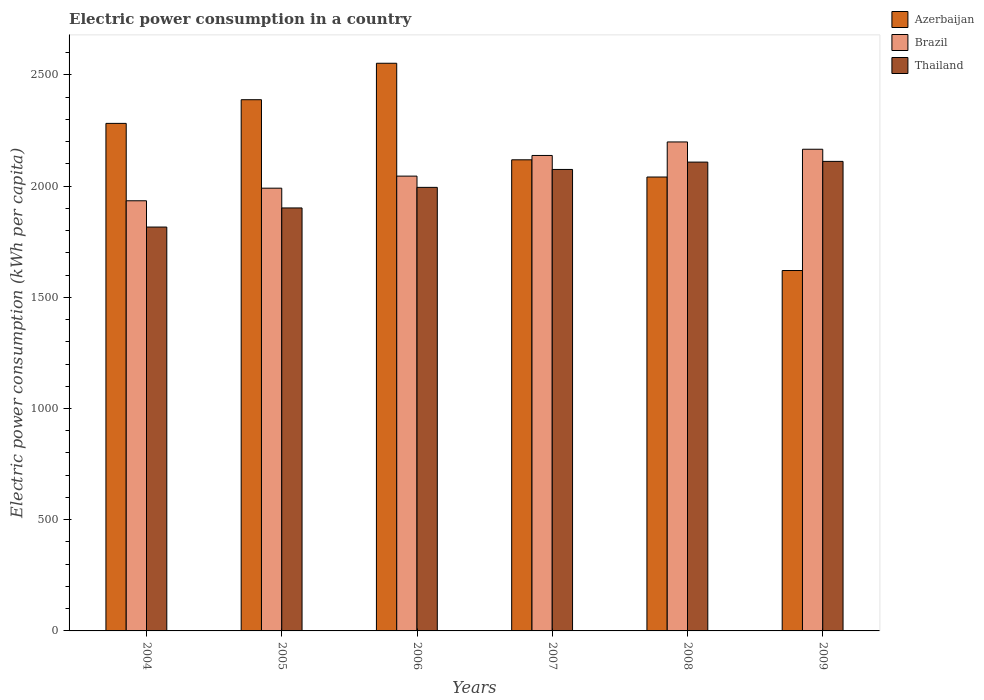How many groups of bars are there?
Make the answer very short. 6. Are the number of bars per tick equal to the number of legend labels?
Offer a very short reply. Yes. Are the number of bars on each tick of the X-axis equal?
Ensure brevity in your answer.  Yes. How many bars are there on the 4th tick from the left?
Keep it short and to the point. 3. In how many cases, is the number of bars for a given year not equal to the number of legend labels?
Provide a short and direct response. 0. What is the electric power consumption in in Brazil in 2006?
Your answer should be very brief. 2044.86. Across all years, what is the maximum electric power consumption in in Thailand?
Your answer should be compact. 2111.13. Across all years, what is the minimum electric power consumption in in Brazil?
Your answer should be compact. 1933.98. In which year was the electric power consumption in in Brazil maximum?
Offer a very short reply. 2008. What is the total electric power consumption in in Azerbaijan in the graph?
Keep it short and to the point. 1.30e+04. What is the difference between the electric power consumption in in Thailand in 2008 and that in 2009?
Make the answer very short. -3.23. What is the difference between the electric power consumption in in Thailand in 2008 and the electric power consumption in in Brazil in 2009?
Offer a very short reply. -57.78. What is the average electric power consumption in in Azerbaijan per year?
Your answer should be compact. 2167. In the year 2004, what is the difference between the electric power consumption in in Thailand and electric power consumption in in Azerbaijan?
Provide a succinct answer. -466.14. What is the ratio of the electric power consumption in in Brazil in 2004 to that in 2006?
Offer a very short reply. 0.95. Is the electric power consumption in in Brazil in 2005 less than that in 2009?
Offer a very short reply. Yes. Is the difference between the electric power consumption in in Thailand in 2004 and 2007 greater than the difference between the electric power consumption in in Azerbaijan in 2004 and 2007?
Provide a succinct answer. No. What is the difference between the highest and the second highest electric power consumption in in Azerbaijan?
Your answer should be compact. 163.9. What is the difference between the highest and the lowest electric power consumption in in Thailand?
Keep it short and to the point. 295.32. What does the 1st bar from the left in 2008 represents?
Your response must be concise. Azerbaijan. What does the 3rd bar from the right in 2008 represents?
Your answer should be compact. Azerbaijan. Is it the case that in every year, the sum of the electric power consumption in in Brazil and electric power consumption in in Azerbaijan is greater than the electric power consumption in in Thailand?
Your answer should be very brief. Yes. How many bars are there?
Provide a short and direct response. 18. How many years are there in the graph?
Offer a terse response. 6. Are the values on the major ticks of Y-axis written in scientific E-notation?
Give a very brief answer. No. Does the graph contain any zero values?
Keep it short and to the point. No. Where does the legend appear in the graph?
Keep it short and to the point. Top right. How are the legend labels stacked?
Provide a short and direct response. Vertical. What is the title of the graph?
Offer a very short reply. Electric power consumption in a country. What is the label or title of the X-axis?
Offer a very short reply. Years. What is the label or title of the Y-axis?
Give a very brief answer. Electric power consumption (kWh per capita). What is the Electric power consumption (kWh per capita) in Azerbaijan in 2004?
Your response must be concise. 2281.95. What is the Electric power consumption (kWh per capita) in Brazil in 2004?
Ensure brevity in your answer.  1933.98. What is the Electric power consumption (kWh per capita) in Thailand in 2004?
Your answer should be very brief. 1815.81. What is the Electric power consumption (kWh per capita) of Azerbaijan in 2005?
Provide a succinct answer. 2388.39. What is the Electric power consumption (kWh per capita) of Brazil in 2005?
Your answer should be very brief. 1990.64. What is the Electric power consumption (kWh per capita) of Thailand in 2005?
Make the answer very short. 1901.78. What is the Electric power consumption (kWh per capita) of Azerbaijan in 2006?
Keep it short and to the point. 2552.29. What is the Electric power consumption (kWh per capita) of Brazil in 2006?
Provide a succinct answer. 2044.86. What is the Electric power consumption (kWh per capita) in Thailand in 2006?
Your response must be concise. 1994.29. What is the Electric power consumption (kWh per capita) in Azerbaijan in 2007?
Give a very brief answer. 2118.21. What is the Electric power consumption (kWh per capita) in Brazil in 2007?
Make the answer very short. 2137.76. What is the Electric power consumption (kWh per capita) of Thailand in 2007?
Make the answer very short. 2074.87. What is the Electric power consumption (kWh per capita) of Azerbaijan in 2008?
Ensure brevity in your answer.  2040.76. What is the Electric power consumption (kWh per capita) of Brazil in 2008?
Make the answer very short. 2198.48. What is the Electric power consumption (kWh per capita) of Thailand in 2008?
Your response must be concise. 2107.9. What is the Electric power consumption (kWh per capita) in Azerbaijan in 2009?
Your answer should be very brief. 1620.39. What is the Electric power consumption (kWh per capita) in Brazil in 2009?
Make the answer very short. 2165.68. What is the Electric power consumption (kWh per capita) of Thailand in 2009?
Make the answer very short. 2111.13. Across all years, what is the maximum Electric power consumption (kWh per capita) in Azerbaijan?
Provide a succinct answer. 2552.29. Across all years, what is the maximum Electric power consumption (kWh per capita) in Brazil?
Ensure brevity in your answer.  2198.48. Across all years, what is the maximum Electric power consumption (kWh per capita) in Thailand?
Make the answer very short. 2111.13. Across all years, what is the minimum Electric power consumption (kWh per capita) of Azerbaijan?
Provide a short and direct response. 1620.39. Across all years, what is the minimum Electric power consumption (kWh per capita) in Brazil?
Offer a terse response. 1933.98. Across all years, what is the minimum Electric power consumption (kWh per capita) of Thailand?
Offer a terse response. 1815.81. What is the total Electric power consumption (kWh per capita) of Azerbaijan in the graph?
Your response must be concise. 1.30e+04. What is the total Electric power consumption (kWh per capita) in Brazil in the graph?
Offer a terse response. 1.25e+04. What is the total Electric power consumption (kWh per capita) of Thailand in the graph?
Keep it short and to the point. 1.20e+04. What is the difference between the Electric power consumption (kWh per capita) of Azerbaijan in 2004 and that in 2005?
Keep it short and to the point. -106.44. What is the difference between the Electric power consumption (kWh per capita) in Brazil in 2004 and that in 2005?
Provide a succinct answer. -56.66. What is the difference between the Electric power consumption (kWh per capita) in Thailand in 2004 and that in 2005?
Provide a succinct answer. -85.98. What is the difference between the Electric power consumption (kWh per capita) of Azerbaijan in 2004 and that in 2006?
Your response must be concise. -270.34. What is the difference between the Electric power consumption (kWh per capita) of Brazil in 2004 and that in 2006?
Make the answer very short. -110.88. What is the difference between the Electric power consumption (kWh per capita) in Thailand in 2004 and that in 2006?
Offer a very short reply. -178.48. What is the difference between the Electric power consumption (kWh per capita) in Azerbaijan in 2004 and that in 2007?
Your answer should be compact. 163.74. What is the difference between the Electric power consumption (kWh per capita) in Brazil in 2004 and that in 2007?
Give a very brief answer. -203.78. What is the difference between the Electric power consumption (kWh per capita) of Thailand in 2004 and that in 2007?
Your answer should be compact. -259.06. What is the difference between the Electric power consumption (kWh per capita) in Azerbaijan in 2004 and that in 2008?
Your response must be concise. 241.19. What is the difference between the Electric power consumption (kWh per capita) of Brazil in 2004 and that in 2008?
Offer a terse response. -264.5. What is the difference between the Electric power consumption (kWh per capita) in Thailand in 2004 and that in 2008?
Provide a succinct answer. -292.1. What is the difference between the Electric power consumption (kWh per capita) of Azerbaijan in 2004 and that in 2009?
Give a very brief answer. 661.56. What is the difference between the Electric power consumption (kWh per capita) of Brazil in 2004 and that in 2009?
Provide a succinct answer. -231.7. What is the difference between the Electric power consumption (kWh per capita) in Thailand in 2004 and that in 2009?
Offer a very short reply. -295.32. What is the difference between the Electric power consumption (kWh per capita) of Azerbaijan in 2005 and that in 2006?
Offer a very short reply. -163.9. What is the difference between the Electric power consumption (kWh per capita) in Brazil in 2005 and that in 2006?
Your answer should be compact. -54.22. What is the difference between the Electric power consumption (kWh per capita) in Thailand in 2005 and that in 2006?
Keep it short and to the point. -92.5. What is the difference between the Electric power consumption (kWh per capita) of Azerbaijan in 2005 and that in 2007?
Keep it short and to the point. 270.18. What is the difference between the Electric power consumption (kWh per capita) of Brazil in 2005 and that in 2007?
Give a very brief answer. -147.12. What is the difference between the Electric power consumption (kWh per capita) in Thailand in 2005 and that in 2007?
Give a very brief answer. -173.09. What is the difference between the Electric power consumption (kWh per capita) of Azerbaijan in 2005 and that in 2008?
Provide a short and direct response. 347.63. What is the difference between the Electric power consumption (kWh per capita) of Brazil in 2005 and that in 2008?
Ensure brevity in your answer.  -207.84. What is the difference between the Electric power consumption (kWh per capita) in Thailand in 2005 and that in 2008?
Ensure brevity in your answer.  -206.12. What is the difference between the Electric power consumption (kWh per capita) of Azerbaijan in 2005 and that in 2009?
Your answer should be very brief. 768. What is the difference between the Electric power consumption (kWh per capita) of Brazil in 2005 and that in 2009?
Give a very brief answer. -175.04. What is the difference between the Electric power consumption (kWh per capita) of Thailand in 2005 and that in 2009?
Provide a short and direct response. -209.35. What is the difference between the Electric power consumption (kWh per capita) in Azerbaijan in 2006 and that in 2007?
Offer a very short reply. 434.08. What is the difference between the Electric power consumption (kWh per capita) in Brazil in 2006 and that in 2007?
Make the answer very short. -92.91. What is the difference between the Electric power consumption (kWh per capita) of Thailand in 2006 and that in 2007?
Your answer should be compact. -80.58. What is the difference between the Electric power consumption (kWh per capita) in Azerbaijan in 2006 and that in 2008?
Ensure brevity in your answer.  511.53. What is the difference between the Electric power consumption (kWh per capita) of Brazil in 2006 and that in 2008?
Keep it short and to the point. -153.62. What is the difference between the Electric power consumption (kWh per capita) in Thailand in 2006 and that in 2008?
Your answer should be very brief. -113.61. What is the difference between the Electric power consumption (kWh per capita) of Azerbaijan in 2006 and that in 2009?
Your answer should be compact. 931.9. What is the difference between the Electric power consumption (kWh per capita) of Brazil in 2006 and that in 2009?
Your answer should be very brief. -120.83. What is the difference between the Electric power consumption (kWh per capita) in Thailand in 2006 and that in 2009?
Your answer should be very brief. -116.84. What is the difference between the Electric power consumption (kWh per capita) in Azerbaijan in 2007 and that in 2008?
Your answer should be very brief. 77.45. What is the difference between the Electric power consumption (kWh per capita) of Brazil in 2007 and that in 2008?
Your answer should be very brief. -60.72. What is the difference between the Electric power consumption (kWh per capita) of Thailand in 2007 and that in 2008?
Provide a short and direct response. -33.03. What is the difference between the Electric power consumption (kWh per capita) in Azerbaijan in 2007 and that in 2009?
Your answer should be compact. 497.82. What is the difference between the Electric power consumption (kWh per capita) in Brazil in 2007 and that in 2009?
Give a very brief answer. -27.92. What is the difference between the Electric power consumption (kWh per capita) of Thailand in 2007 and that in 2009?
Make the answer very short. -36.26. What is the difference between the Electric power consumption (kWh per capita) in Azerbaijan in 2008 and that in 2009?
Provide a short and direct response. 420.37. What is the difference between the Electric power consumption (kWh per capita) of Brazil in 2008 and that in 2009?
Your answer should be compact. 32.8. What is the difference between the Electric power consumption (kWh per capita) of Thailand in 2008 and that in 2009?
Offer a terse response. -3.23. What is the difference between the Electric power consumption (kWh per capita) in Azerbaijan in 2004 and the Electric power consumption (kWh per capita) in Brazil in 2005?
Ensure brevity in your answer.  291.3. What is the difference between the Electric power consumption (kWh per capita) of Azerbaijan in 2004 and the Electric power consumption (kWh per capita) of Thailand in 2005?
Make the answer very short. 380.16. What is the difference between the Electric power consumption (kWh per capita) of Brazil in 2004 and the Electric power consumption (kWh per capita) of Thailand in 2005?
Give a very brief answer. 32.2. What is the difference between the Electric power consumption (kWh per capita) of Azerbaijan in 2004 and the Electric power consumption (kWh per capita) of Brazil in 2006?
Give a very brief answer. 237.09. What is the difference between the Electric power consumption (kWh per capita) in Azerbaijan in 2004 and the Electric power consumption (kWh per capita) in Thailand in 2006?
Your answer should be compact. 287.66. What is the difference between the Electric power consumption (kWh per capita) of Brazil in 2004 and the Electric power consumption (kWh per capita) of Thailand in 2006?
Offer a very short reply. -60.3. What is the difference between the Electric power consumption (kWh per capita) of Azerbaijan in 2004 and the Electric power consumption (kWh per capita) of Brazil in 2007?
Ensure brevity in your answer.  144.18. What is the difference between the Electric power consumption (kWh per capita) of Azerbaijan in 2004 and the Electric power consumption (kWh per capita) of Thailand in 2007?
Provide a short and direct response. 207.08. What is the difference between the Electric power consumption (kWh per capita) of Brazil in 2004 and the Electric power consumption (kWh per capita) of Thailand in 2007?
Your answer should be compact. -140.89. What is the difference between the Electric power consumption (kWh per capita) in Azerbaijan in 2004 and the Electric power consumption (kWh per capita) in Brazil in 2008?
Your response must be concise. 83.46. What is the difference between the Electric power consumption (kWh per capita) in Azerbaijan in 2004 and the Electric power consumption (kWh per capita) in Thailand in 2008?
Ensure brevity in your answer.  174.05. What is the difference between the Electric power consumption (kWh per capita) in Brazil in 2004 and the Electric power consumption (kWh per capita) in Thailand in 2008?
Provide a succinct answer. -173.92. What is the difference between the Electric power consumption (kWh per capita) in Azerbaijan in 2004 and the Electric power consumption (kWh per capita) in Brazil in 2009?
Offer a terse response. 116.26. What is the difference between the Electric power consumption (kWh per capita) in Azerbaijan in 2004 and the Electric power consumption (kWh per capita) in Thailand in 2009?
Offer a terse response. 170.82. What is the difference between the Electric power consumption (kWh per capita) in Brazil in 2004 and the Electric power consumption (kWh per capita) in Thailand in 2009?
Offer a very short reply. -177.15. What is the difference between the Electric power consumption (kWh per capita) in Azerbaijan in 2005 and the Electric power consumption (kWh per capita) in Brazil in 2006?
Make the answer very short. 343.53. What is the difference between the Electric power consumption (kWh per capita) of Azerbaijan in 2005 and the Electric power consumption (kWh per capita) of Thailand in 2006?
Keep it short and to the point. 394.1. What is the difference between the Electric power consumption (kWh per capita) of Brazil in 2005 and the Electric power consumption (kWh per capita) of Thailand in 2006?
Keep it short and to the point. -3.64. What is the difference between the Electric power consumption (kWh per capita) in Azerbaijan in 2005 and the Electric power consumption (kWh per capita) in Brazil in 2007?
Make the answer very short. 250.62. What is the difference between the Electric power consumption (kWh per capita) in Azerbaijan in 2005 and the Electric power consumption (kWh per capita) in Thailand in 2007?
Make the answer very short. 313.52. What is the difference between the Electric power consumption (kWh per capita) in Brazil in 2005 and the Electric power consumption (kWh per capita) in Thailand in 2007?
Provide a short and direct response. -84.23. What is the difference between the Electric power consumption (kWh per capita) in Azerbaijan in 2005 and the Electric power consumption (kWh per capita) in Brazil in 2008?
Offer a terse response. 189.91. What is the difference between the Electric power consumption (kWh per capita) of Azerbaijan in 2005 and the Electric power consumption (kWh per capita) of Thailand in 2008?
Make the answer very short. 280.49. What is the difference between the Electric power consumption (kWh per capita) of Brazil in 2005 and the Electric power consumption (kWh per capita) of Thailand in 2008?
Provide a succinct answer. -117.26. What is the difference between the Electric power consumption (kWh per capita) of Azerbaijan in 2005 and the Electric power consumption (kWh per capita) of Brazil in 2009?
Provide a short and direct response. 222.7. What is the difference between the Electric power consumption (kWh per capita) in Azerbaijan in 2005 and the Electric power consumption (kWh per capita) in Thailand in 2009?
Give a very brief answer. 277.26. What is the difference between the Electric power consumption (kWh per capita) of Brazil in 2005 and the Electric power consumption (kWh per capita) of Thailand in 2009?
Make the answer very short. -120.49. What is the difference between the Electric power consumption (kWh per capita) in Azerbaijan in 2006 and the Electric power consumption (kWh per capita) in Brazil in 2007?
Make the answer very short. 414.52. What is the difference between the Electric power consumption (kWh per capita) in Azerbaijan in 2006 and the Electric power consumption (kWh per capita) in Thailand in 2007?
Provide a short and direct response. 477.42. What is the difference between the Electric power consumption (kWh per capita) of Brazil in 2006 and the Electric power consumption (kWh per capita) of Thailand in 2007?
Your answer should be very brief. -30.01. What is the difference between the Electric power consumption (kWh per capita) of Azerbaijan in 2006 and the Electric power consumption (kWh per capita) of Brazil in 2008?
Your response must be concise. 353.8. What is the difference between the Electric power consumption (kWh per capita) in Azerbaijan in 2006 and the Electric power consumption (kWh per capita) in Thailand in 2008?
Give a very brief answer. 444.38. What is the difference between the Electric power consumption (kWh per capita) in Brazil in 2006 and the Electric power consumption (kWh per capita) in Thailand in 2008?
Offer a terse response. -63.04. What is the difference between the Electric power consumption (kWh per capita) of Azerbaijan in 2006 and the Electric power consumption (kWh per capita) of Brazil in 2009?
Your answer should be very brief. 386.6. What is the difference between the Electric power consumption (kWh per capita) in Azerbaijan in 2006 and the Electric power consumption (kWh per capita) in Thailand in 2009?
Offer a very short reply. 441.15. What is the difference between the Electric power consumption (kWh per capita) in Brazil in 2006 and the Electric power consumption (kWh per capita) in Thailand in 2009?
Ensure brevity in your answer.  -66.27. What is the difference between the Electric power consumption (kWh per capita) in Azerbaijan in 2007 and the Electric power consumption (kWh per capita) in Brazil in 2008?
Your answer should be compact. -80.27. What is the difference between the Electric power consumption (kWh per capita) of Azerbaijan in 2007 and the Electric power consumption (kWh per capita) of Thailand in 2008?
Provide a short and direct response. 10.31. What is the difference between the Electric power consumption (kWh per capita) of Brazil in 2007 and the Electric power consumption (kWh per capita) of Thailand in 2008?
Offer a very short reply. 29.86. What is the difference between the Electric power consumption (kWh per capita) of Azerbaijan in 2007 and the Electric power consumption (kWh per capita) of Brazil in 2009?
Provide a short and direct response. -47.47. What is the difference between the Electric power consumption (kWh per capita) in Azerbaijan in 2007 and the Electric power consumption (kWh per capita) in Thailand in 2009?
Your answer should be very brief. 7.08. What is the difference between the Electric power consumption (kWh per capita) in Brazil in 2007 and the Electric power consumption (kWh per capita) in Thailand in 2009?
Provide a short and direct response. 26.63. What is the difference between the Electric power consumption (kWh per capita) in Azerbaijan in 2008 and the Electric power consumption (kWh per capita) in Brazil in 2009?
Provide a short and direct response. -124.92. What is the difference between the Electric power consumption (kWh per capita) of Azerbaijan in 2008 and the Electric power consumption (kWh per capita) of Thailand in 2009?
Provide a short and direct response. -70.37. What is the difference between the Electric power consumption (kWh per capita) of Brazil in 2008 and the Electric power consumption (kWh per capita) of Thailand in 2009?
Make the answer very short. 87.35. What is the average Electric power consumption (kWh per capita) of Azerbaijan per year?
Offer a terse response. 2167. What is the average Electric power consumption (kWh per capita) in Brazil per year?
Offer a terse response. 2078.57. What is the average Electric power consumption (kWh per capita) of Thailand per year?
Provide a succinct answer. 2000.96. In the year 2004, what is the difference between the Electric power consumption (kWh per capita) of Azerbaijan and Electric power consumption (kWh per capita) of Brazil?
Your answer should be compact. 347.96. In the year 2004, what is the difference between the Electric power consumption (kWh per capita) in Azerbaijan and Electric power consumption (kWh per capita) in Thailand?
Ensure brevity in your answer.  466.14. In the year 2004, what is the difference between the Electric power consumption (kWh per capita) in Brazil and Electric power consumption (kWh per capita) in Thailand?
Offer a terse response. 118.18. In the year 2005, what is the difference between the Electric power consumption (kWh per capita) in Azerbaijan and Electric power consumption (kWh per capita) in Brazil?
Offer a terse response. 397.75. In the year 2005, what is the difference between the Electric power consumption (kWh per capita) in Azerbaijan and Electric power consumption (kWh per capita) in Thailand?
Give a very brief answer. 486.61. In the year 2005, what is the difference between the Electric power consumption (kWh per capita) in Brazil and Electric power consumption (kWh per capita) in Thailand?
Your answer should be very brief. 88.86. In the year 2006, what is the difference between the Electric power consumption (kWh per capita) in Azerbaijan and Electric power consumption (kWh per capita) in Brazil?
Keep it short and to the point. 507.43. In the year 2006, what is the difference between the Electric power consumption (kWh per capita) in Azerbaijan and Electric power consumption (kWh per capita) in Thailand?
Your response must be concise. 558. In the year 2006, what is the difference between the Electric power consumption (kWh per capita) in Brazil and Electric power consumption (kWh per capita) in Thailand?
Offer a very short reply. 50.57. In the year 2007, what is the difference between the Electric power consumption (kWh per capita) of Azerbaijan and Electric power consumption (kWh per capita) of Brazil?
Make the answer very short. -19.55. In the year 2007, what is the difference between the Electric power consumption (kWh per capita) in Azerbaijan and Electric power consumption (kWh per capita) in Thailand?
Keep it short and to the point. 43.34. In the year 2007, what is the difference between the Electric power consumption (kWh per capita) in Brazil and Electric power consumption (kWh per capita) in Thailand?
Provide a short and direct response. 62.9. In the year 2008, what is the difference between the Electric power consumption (kWh per capita) of Azerbaijan and Electric power consumption (kWh per capita) of Brazil?
Ensure brevity in your answer.  -157.72. In the year 2008, what is the difference between the Electric power consumption (kWh per capita) of Azerbaijan and Electric power consumption (kWh per capita) of Thailand?
Provide a succinct answer. -67.14. In the year 2008, what is the difference between the Electric power consumption (kWh per capita) of Brazil and Electric power consumption (kWh per capita) of Thailand?
Provide a succinct answer. 90.58. In the year 2009, what is the difference between the Electric power consumption (kWh per capita) of Azerbaijan and Electric power consumption (kWh per capita) of Brazil?
Your answer should be compact. -545.3. In the year 2009, what is the difference between the Electric power consumption (kWh per capita) of Azerbaijan and Electric power consumption (kWh per capita) of Thailand?
Give a very brief answer. -490.74. In the year 2009, what is the difference between the Electric power consumption (kWh per capita) in Brazil and Electric power consumption (kWh per capita) in Thailand?
Offer a very short reply. 54.55. What is the ratio of the Electric power consumption (kWh per capita) in Azerbaijan in 2004 to that in 2005?
Provide a short and direct response. 0.96. What is the ratio of the Electric power consumption (kWh per capita) in Brazil in 2004 to that in 2005?
Provide a succinct answer. 0.97. What is the ratio of the Electric power consumption (kWh per capita) of Thailand in 2004 to that in 2005?
Your response must be concise. 0.95. What is the ratio of the Electric power consumption (kWh per capita) in Azerbaijan in 2004 to that in 2006?
Keep it short and to the point. 0.89. What is the ratio of the Electric power consumption (kWh per capita) in Brazil in 2004 to that in 2006?
Offer a terse response. 0.95. What is the ratio of the Electric power consumption (kWh per capita) in Thailand in 2004 to that in 2006?
Provide a short and direct response. 0.91. What is the ratio of the Electric power consumption (kWh per capita) of Azerbaijan in 2004 to that in 2007?
Provide a short and direct response. 1.08. What is the ratio of the Electric power consumption (kWh per capita) of Brazil in 2004 to that in 2007?
Give a very brief answer. 0.9. What is the ratio of the Electric power consumption (kWh per capita) in Thailand in 2004 to that in 2007?
Your answer should be compact. 0.88. What is the ratio of the Electric power consumption (kWh per capita) in Azerbaijan in 2004 to that in 2008?
Your answer should be compact. 1.12. What is the ratio of the Electric power consumption (kWh per capita) of Brazil in 2004 to that in 2008?
Offer a very short reply. 0.88. What is the ratio of the Electric power consumption (kWh per capita) in Thailand in 2004 to that in 2008?
Your answer should be very brief. 0.86. What is the ratio of the Electric power consumption (kWh per capita) in Azerbaijan in 2004 to that in 2009?
Offer a very short reply. 1.41. What is the ratio of the Electric power consumption (kWh per capita) of Brazil in 2004 to that in 2009?
Your answer should be compact. 0.89. What is the ratio of the Electric power consumption (kWh per capita) of Thailand in 2004 to that in 2009?
Offer a very short reply. 0.86. What is the ratio of the Electric power consumption (kWh per capita) of Azerbaijan in 2005 to that in 2006?
Provide a short and direct response. 0.94. What is the ratio of the Electric power consumption (kWh per capita) in Brazil in 2005 to that in 2006?
Provide a succinct answer. 0.97. What is the ratio of the Electric power consumption (kWh per capita) of Thailand in 2005 to that in 2006?
Ensure brevity in your answer.  0.95. What is the ratio of the Electric power consumption (kWh per capita) in Azerbaijan in 2005 to that in 2007?
Give a very brief answer. 1.13. What is the ratio of the Electric power consumption (kWh per capita) in Brazil in 2005 to that in 2007?
Make the answer very short. 0.93. What is the ratio of the Electric power consumption (kWh per capita) in Thailand in 2005 to that in 2007?
Give a very brief answer. 0.92. What is the ratio of the Electric power consumption (kWh per capita) in Azerbaijan in 2005 to that in 2008?
Ensure brevity in your answer.  1.17. What is the ratio of the Electric power consumption (kWh per capita) of Brazil in 2005 to that in 2008?
Your response must be concise. 0.91. What is the ratio of the Electric power consumption (kWh per capita) of Thailand in 2005 to that in 2008?
Your answer should be compact. 0.9. What is the ratio of the Electric power consumption (kWh per capita) in Azerbaijan in 2005 to that in 2009?
Your answer should be compact. 1.47. What is the ratio of the Electric power consumption (kWh per capita) in Brazil in 2005 to that in 2009?
Give a very brief answer. 0.92. What is the ratio of the Electric power consumption (kWh per capita) in Thailand in 2005 to that in 2009?
Your answer should be compact. 0.9. What is the ratio of the Electric power consumption (kWh per capita) of Azerbaijan in 2006 to that in 2007?
Keep it short and to the point. 1.2. What is the ratio of the Electric power consumption (kWh per capita) of Brazil in 2006 to that in 2007?
Keep it short and to the point. 0.96. What is the ratio of the Electric power consumption (kWh per capita) of Thailand in 2006 to that in 2007?
Offer a very short reply. 0.96. What is the ratio of the Electric power consumption (kWh per capita) in Azerbaijan in 2006 to that in 2008?
Your response must be concise. 1.25. What is the ratio of the Electric power consumption (kWh per capita) of Brazil in 2006 to that in 2008?
Your answer should be compact. 0.93. What is the ratio of the Electric power consumption (kWh per capita) in Thailand in 2006 to that in 2008?
Offer a terse response. 0.95. What is the ratio of the Electric power consumption (kWh per capita) in Azerbaijan in 2006 to that in 2009?
Your answer should be compact. 1.58. What is the ratio of the Electric power consumption (kWh per capita) in Brazil in 2006 to that in 2009?
Make the answer very short. 0.94. What is the ratio of the Electric power consumption (kWh per capita) in Thailand in 2006 to that in 2009?
Offer a terse response. 0.94. What is the ratio of the Electric power consumption (kWh per capita) in Azerbaijan in 2007 to that in 2008?
Your answer should be very brief. 1.04. What is the ratio of the Electric power consumption (kWh per capita) in Brazil in 2007 to that in 2008?
Keep it short and to the point. 0.97. What is the ratio of the Electric power consumption (kWh per capita) in Thailand in 2007 to that in 2008?
Provide a succinct answer. 0.98. What is the ratio of the Electric power consumption (kWh per capita) in Azerbaijan in 2007 to that in 2009?
Offer a terse response. 1.31. What is the ratio of the Electric power consumption (kWh per capita) of Brazil in 2007 to that in 2009?
Your answer should be very brief. 0.99. What is the ratio of the Electric power consumption (kWh per capita) in Thailand in 2007 to that in 2009?
Your answer should be very brief. 0.98. What is the ratio of the Electric power consumption (kWh per capita) of Azerbaijan in 2008 to that in 2009?
Provide a short and direct response. 1.26. What is the ratio of the Electric power consumption (kWh per capita) in Brazil in 2008 to that in 2009?
Offer a very short reply. 1.02. What is the ratio of the Electric power consumption (kWh per capita) in Thailand in 2008 to that in 2009?
Keep it short and to the point. 1. What is the difference between the highest and the second highest Electric power consumption (kWh per capita) of Azerbaijan?
Keep it short and to the point. 163.9. What is the difference between the highest and the second highest Electric power consumption (kWh per capita) of Brazil?
Offer a terse response. 32.8. What is the difference between the highest and the second highest Electric power consumption (kWh per capita) in Thailand?
Your answer should be very brief. 3.23. What is the difference between the highest and the lowest Electric power consumption (kWh per capita) of Azerbaijan?
Make the answer very short. 931.9. What is the difference between the highest and the lowest Electric power consumption (kWh per capita) of Brazil?
Your answer should be very brief. 264.5. What is the difference between the highest and the lowest Electric power consumption (kWh per capita) of Thailand?
Keep it short and to the point. 295.32. 